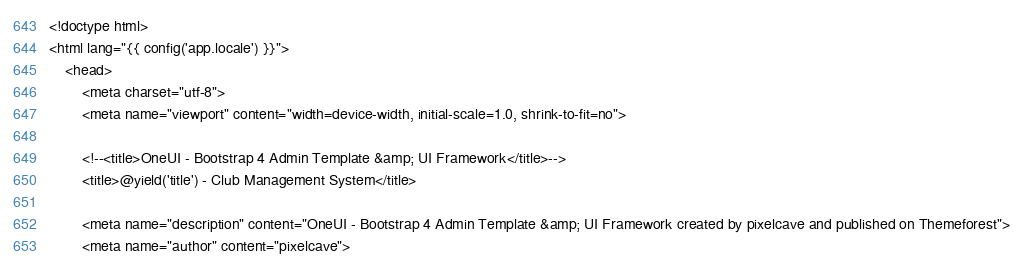<code> <loc_0><loc_0><loc_500><loc_500><_PHP_><!doctype html>
<html lang="{{ config('app.locale') }}">
    <head>
        <meta charset="utf-8">
        <meta name="viewport" content="width=device-width, initial-scale=1.0, shrink-to-fit=no">

        <!--<title>OneUI - Bootstrap 4 Admin Template &amp; UI Framework</title>-->
        <title>@yield('title') - Club Management System</title>

        <meta name="description" content="OneUI - Bootstrap 4 Admin Template &amp; UI Framework created by pixelcave and published on Themeforest">
        <meta name="author" content="pixelcave"></code> 